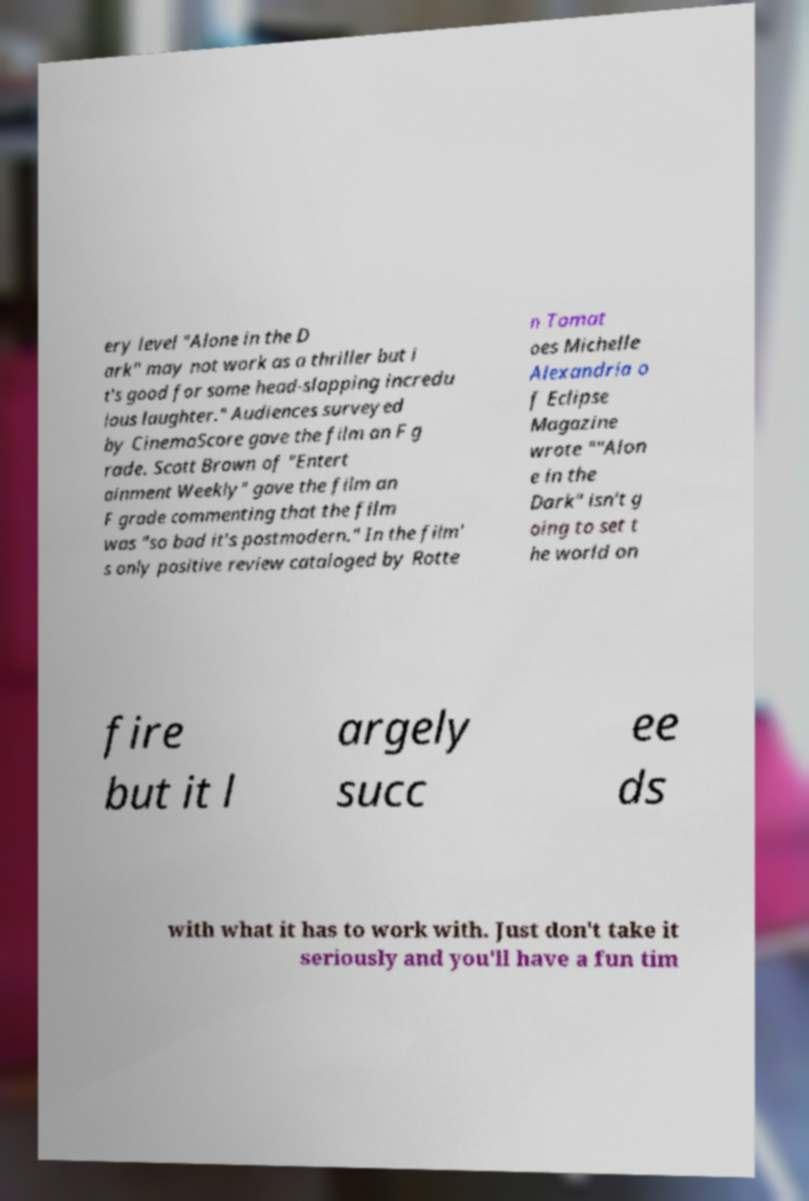What messages or text are displayed in this image? I need them in a readable, typed format. ery level "Alone in the D ark" may not work as a thriller but i t's good for some head-slapping incredu lous laughter." Audiences surveyed by CinemaScore gave the film an F g rade. Scott Brown of "Entert ainment Weekly" gave the film an F grade commenting that the film was "so bad it's postmodern." In the film' s only positive review cataloged by Rotte n Tomat oes Michelle Alexandria o f Eclipse Magazine wrote ""Alon e in the Dark" isn't g oing to set t he world on fire but it l argely succ ee ds with what it has to work with. Just don't take it seriously and you'll have a fun tim 